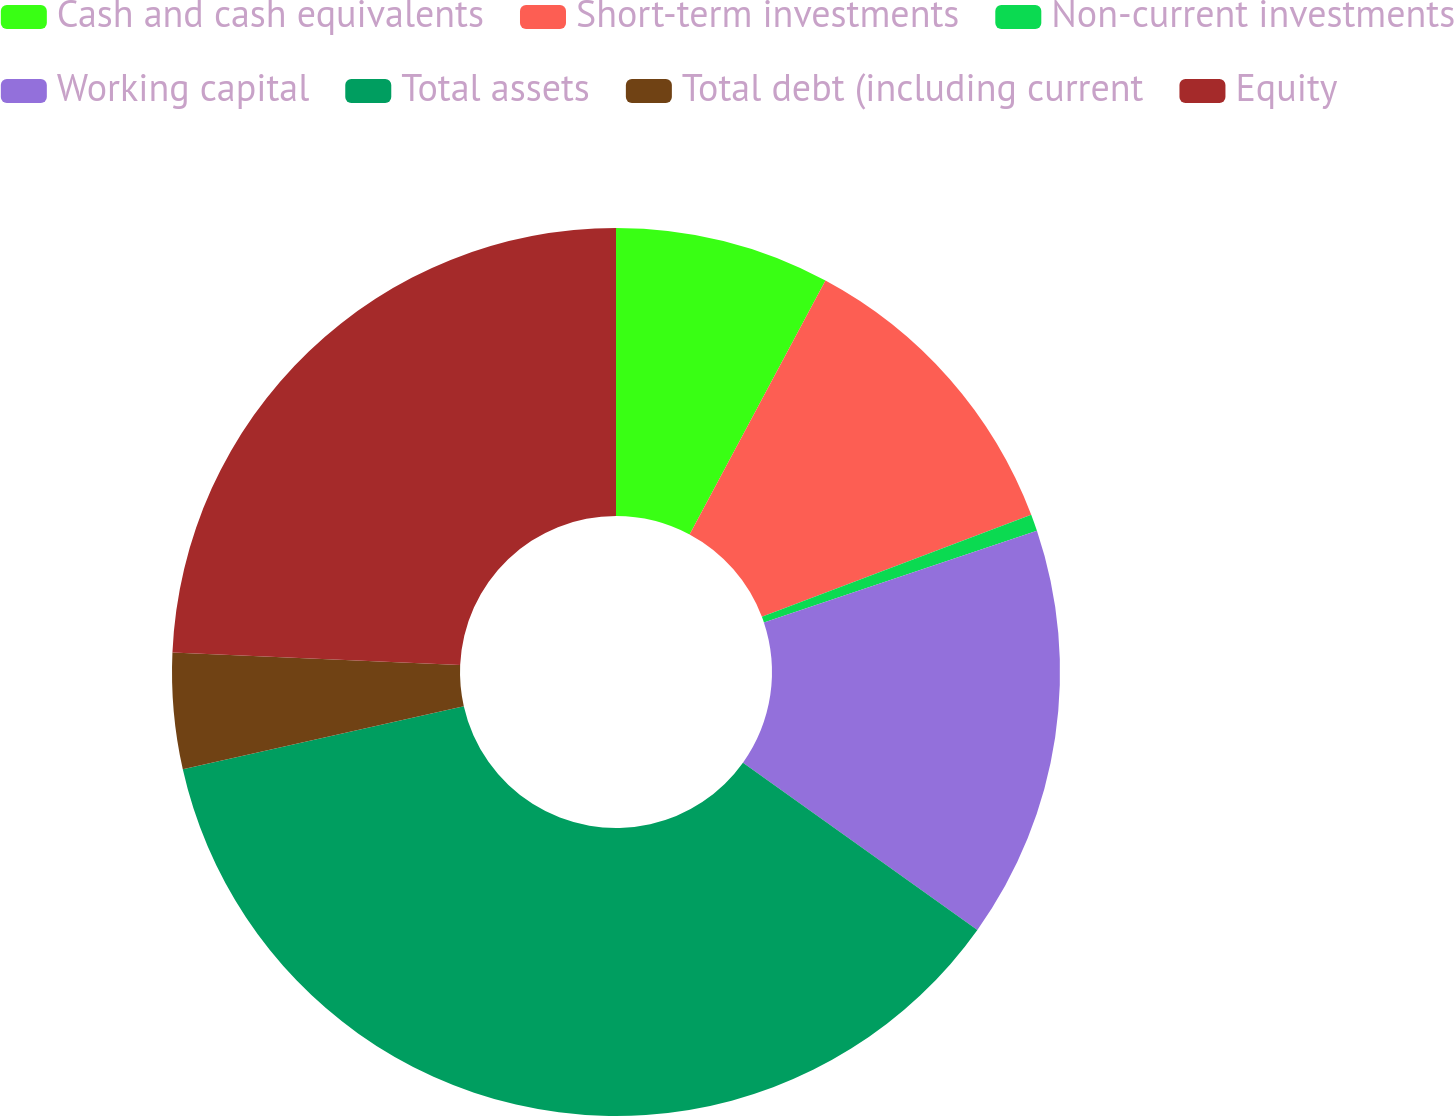Convert chart to OTSL. <chart><loc_0><loc_0><loc_500><loc_500><pie_chart><fcel>Cash and cash equivalents<fcel>Short-term investments<fcel>Non-current investments<fcel>Working capital<fcel>Total assets<fcel>Total debt (including current<fcel>Equity<nl><fcel>7.82%<fcel>11.42%<fcel>0.61%<fcel>15.02%<fcel>36.62%<fcel>4.22%<fcel>24.3%<nl></chart> 